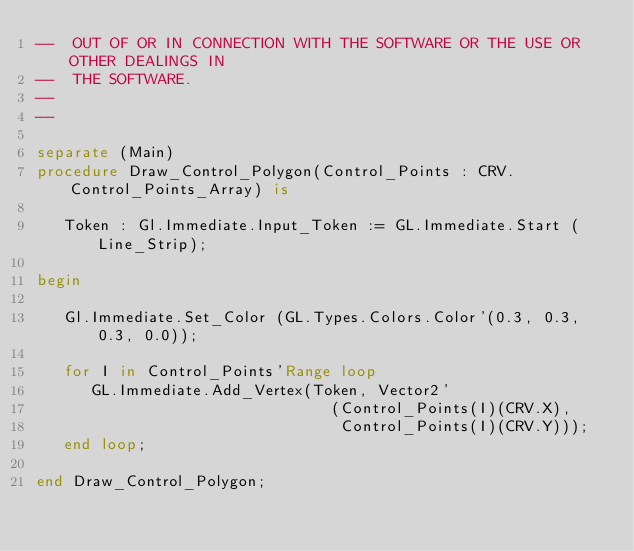Convert code to text. <code><loc_0><loc_0><loc_500><loc_500><_Ada_>--  OUT OF OR IN CONNECTION WITH THE SOFTWARE OR THE USE OR OTHER DEALINGS IN
--  THE SOFTWARE.
-- 
--

separate (Main)
procedure Draw_Control_Polygon(Control_Points : CRV.Control_Points_Array) is
   
   Token : Gl.Immediate.Input_Token := GL.Immediate.Start (Line_Strip);
   
begin
    
   Gl.Immediate.Set_Color (GL.Types.Colors.Color'(0.3, 0.3, 0.3, 0.0));
   
   for I in Control_Points'Range loop
      GL.Immediate.Add_Vertex(Token, Vector2'
                                (Control_Points(I)(CRV.X), 
                                 Control_Points(I)(CRV.Y)));
   end loop;         
   
end Draw_Control_Polygon;
</code> 